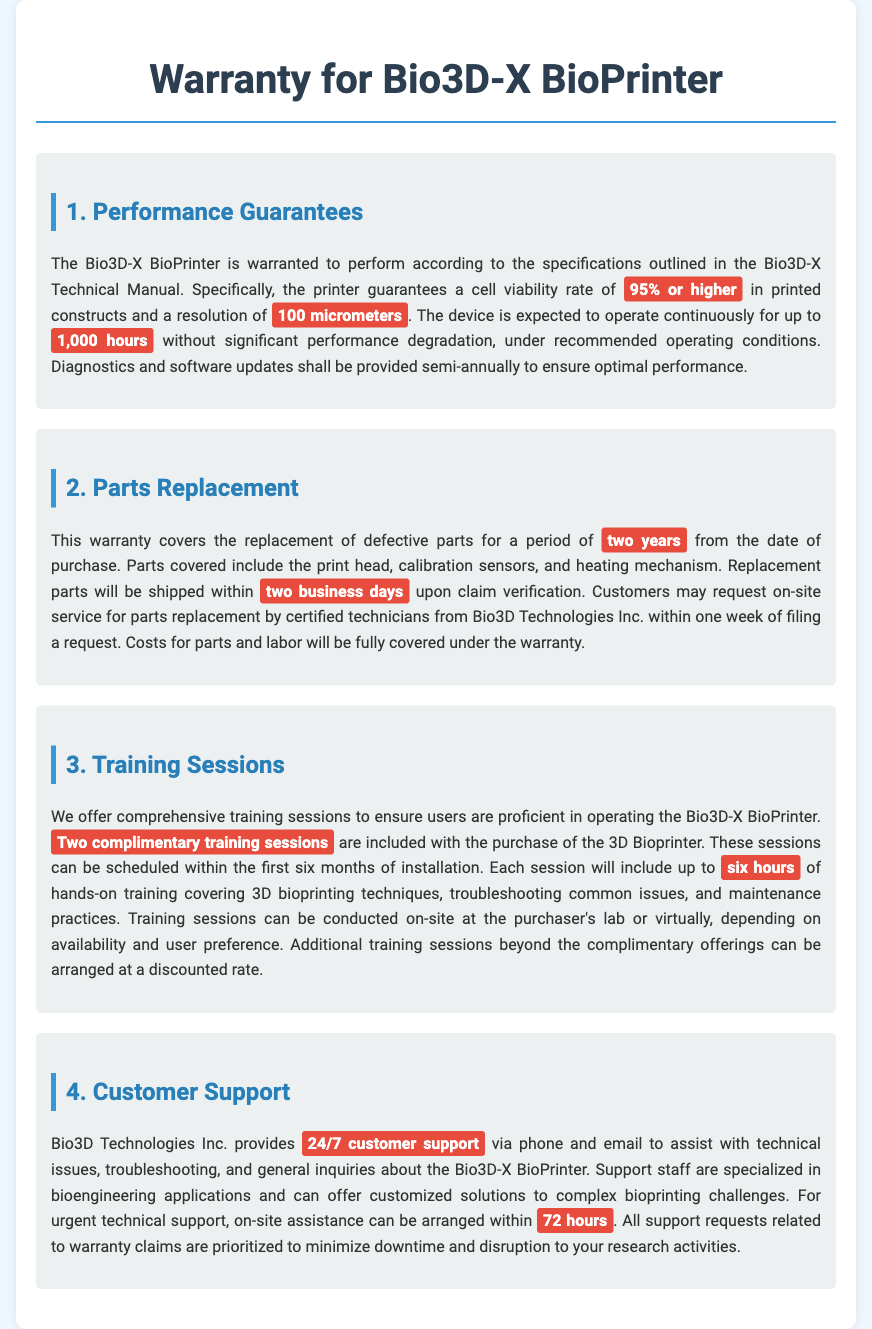what is the guaranteed cell viability rate for printed constructs? The document states that the printer guarantees a cell viability rate of 95% or higher.
Answer: 95% or higher how long is the warranty period for parts replacement? The warranty covers the replacement of defective parts for a period of two years from the date of purchase.
Answer: two years how quickly are replacement parts shipped? The document specifies that replacement parts will be shipped within two business days upon claim verification.
Answer: two business days how many training sessions are included with the purchase? The warranty includes two complimentary training sessions with the purchase of the 3D Bioprinter.
Answer: two how many hours of training are covered in each session? Each training session includes up to six hours of hands-on training.
Answer: six hours what are the support hours provided by Bio3D Technologies Inc.? The document mentions that customer support is available 24/7 via phone and email for assistance.
Answer: 24/7 within how many hours can urgent technical support be arranged on-site? Urgent technical support can be arranged on-site within 72 hours as per the warranty document.
Answer: 72 hours what is the expected continuous operation time without performance degradation? The document states that the device is expected to operate continuously for up to 1,000 hours without significant performance degradation.
Answer: 1,000 hours who provides the training sessions for the Bio3D-X BioPrinter? The document implies that training sessions are provided by Bio3D Technologies Inc. as part of the warranty.
Answer: Bio3D Technologies Inc 